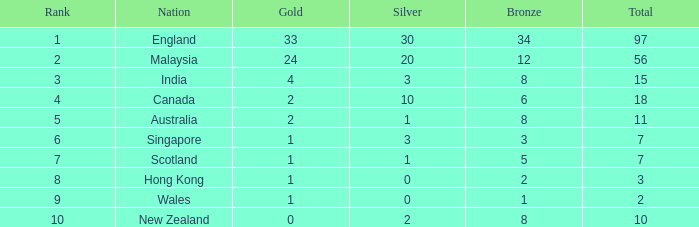What's the mean number of silver medals for a team possessing 1 gold and more than 5 bronze medals? None. Can you give me this table as a dict? {'header': ['Rank', 'Nation', 'Gold', 'Silver', 'Bronze', 'Total'], 'rows': [['1', 'England', '33', '30', '34', '97'], ['2', 'Malaysia', '24', '20', '12', '56'], ['3', 'India', '4', '3', '8', '15'], ['4', 'Canada', '2', '10', '6', '18'], ['5', 'Australia', '2', '1', '8', '11'], ['6', 'Singapore', '1', '3', '3', '7'], ['7', 'Scotland', '1', '1', '5', '7'], ['8', 'Hong Kong', '1', '0', '2', '3'], ['9', 'Wales', '1', '0', '1', '2'], ['10', 'New Zealand', '0', '2', '8', '10']]} 